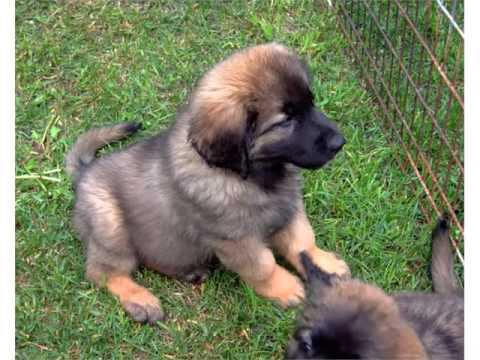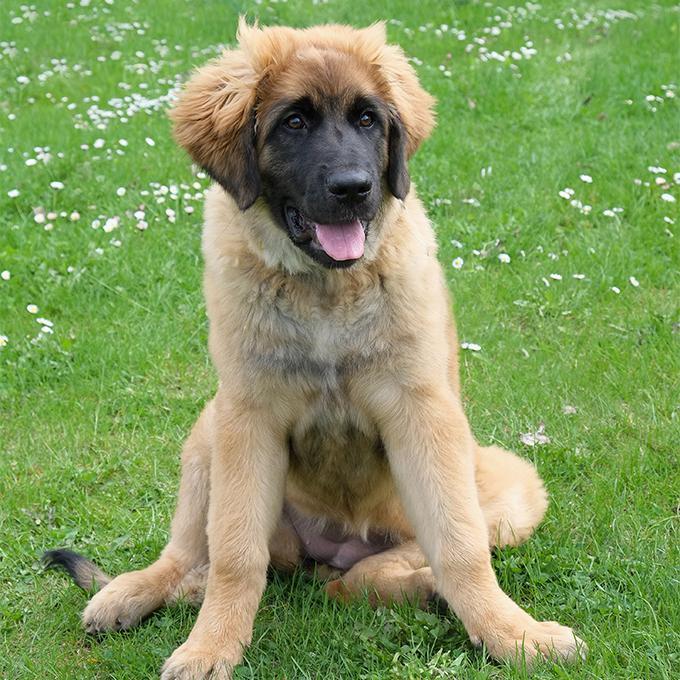The first image is the image on the left, the second image is the image on the right. Analyze the images presented: Is the assertion "In one of the images, a human can be seen walking at least one dog." valid? Answer yes or no. No. The first image is the image on the left, the second image is the image on the right. For the images shown, is this caption "One image has a person standing next to a dog in the city." true? Answer yes or no. No. 